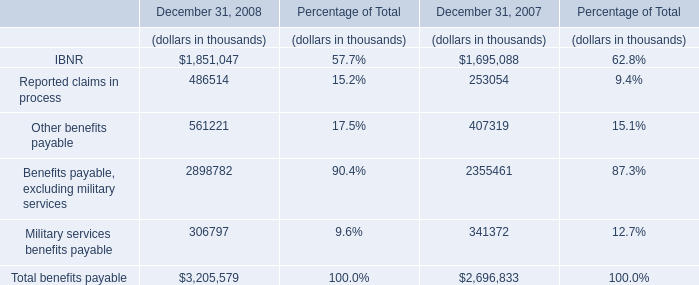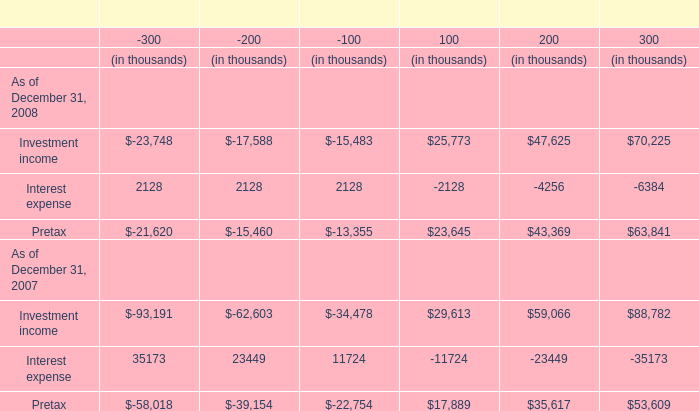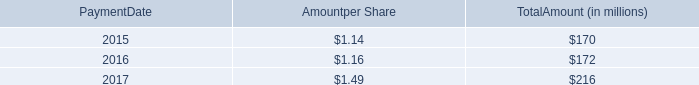what is the percentage of the common stock repurchase among the total program of repurchases? 
Computations: (1.5 / 2.25)
Answer: 0.66667. 